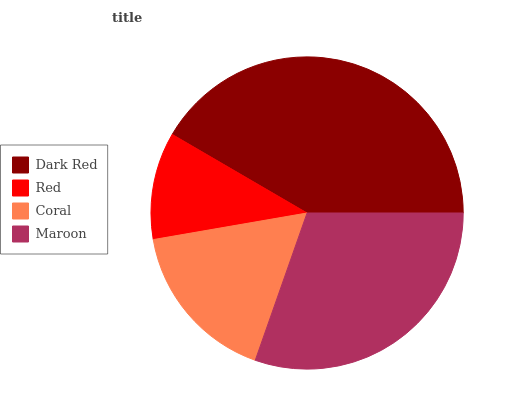Is Red the minimum?
Answer yes or no. Yes. Is Dark Red the maximum?
Answer yes or no. Yes. Is Coral the minimum?
Answer yes or no. No. Is Coral the maximum?
Answer yes or no. No. Is Coral greater than Red?
Answer yes or no. Yes. Is Red less than Coral?
Answer yes or no. Yes. Is Red greater than Coral?
Answer yes or no. No. Is Coral less than Red?
Answer yes or no. No. Is Maroon the high median?
Answer yes or no. Yes. Is Coral the low median?
Answer yes or no. Yes. Is Coral the high median?
Answer yes or no. No. Is Maroon the low median?
Answer yes or no. No. 